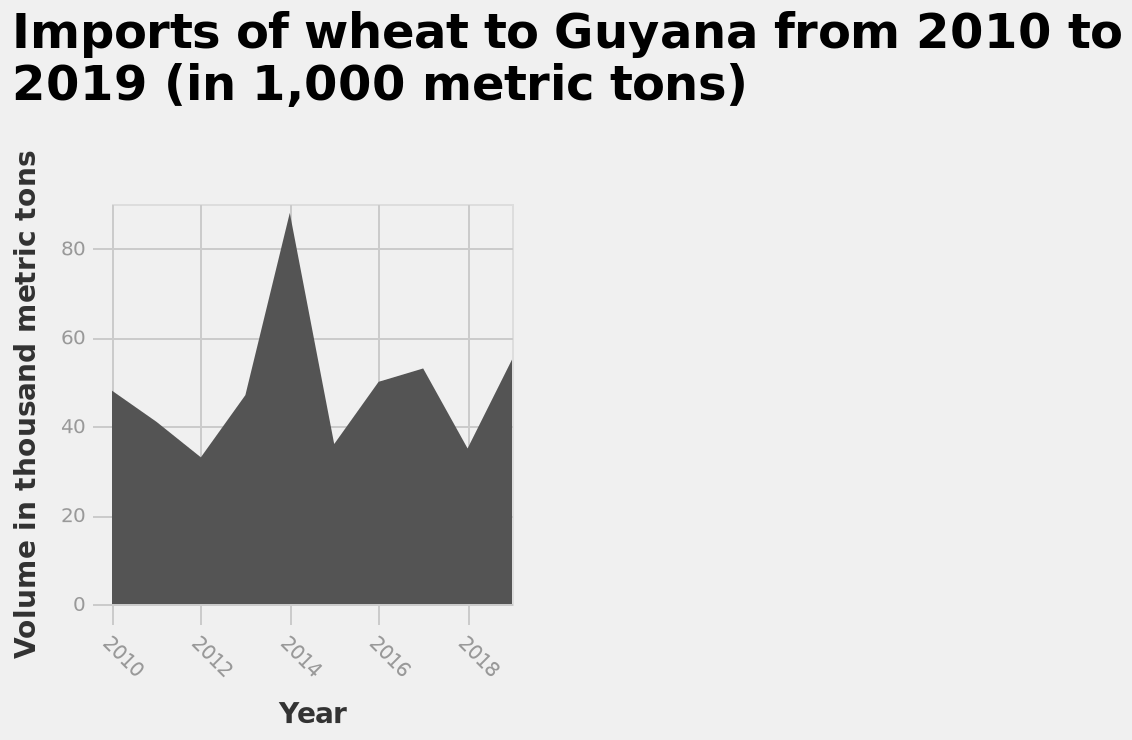<image>
Offer a thorough analysis of the image. Wheat import was the highest in 2014 reaching above 80 metric tons while on average it has hovered around 40/50 for every other year. What is the range of the y-axis?  The range of the y-axis is from 0 to 80 thousand metric tons. 